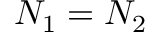<formula> <loc_0><loc_0><loc_500><loc_500>N _ { 1 } = N _ { 2 }</formula> 